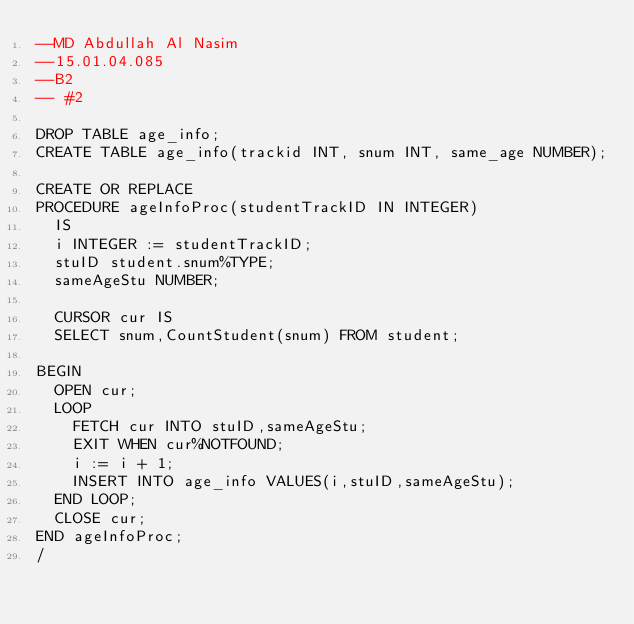Convert code to text. <code><loc_0><loc_0><loc_500><loc_500><_SQL_>--MD Abdullah Al Nasim
--15.01.04.085
--B2
-- #2

DROP TABLE age_info;
CREATE TABLE age_info(trackid INT, snum INT, same_age NUMBER);

CREATE OR REPLACE
PROCEDURE ageInfoProc(studentTrackID IN INTEGER)
	IS
	i INTEGER := studentTrackID;
	stuID student.snum%TYPE;
	sameAgeStu NUMBER;
	
	CURSOR cur IS
	SELECT snum,CountStudent(snum) FROM student;

BEGIN
	OPEN cur;
	LOOP
		FETCH cur INTO stuID,sameAgeStu;
		EXIT WHEN cur%NOTFOUND;
		i := i + 1;
		INSERT INTO age_info VALUES(i,stuID,sameAgeStu);
	END LOOP;
	CLOSE cur;
END ageInfoProc;
/</code> 